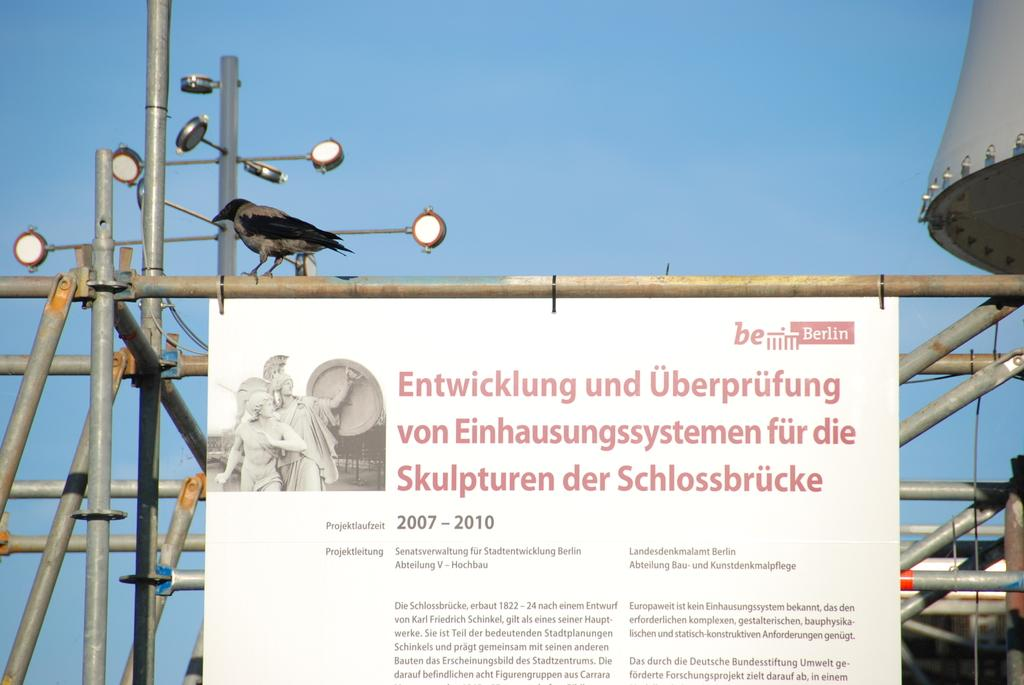<image>
Render a clear and concise summary of the photo. A sign hangs from a scaffold with Berlin in the upper right corner. 